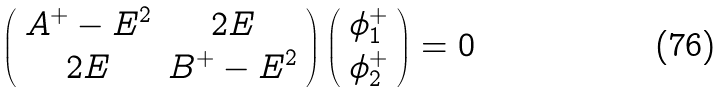<formula> <loc_0><loc_0><loc_500><loc_500>\left ( \begin{array} { c c } A ^ { + } - E ^ { 2 } & 2 E \\ 2 E & B ^ { + } - E ^ { 2 } \end{array} \right ) \left ( \begin{array} { c } \phi ^ { + } _ { 1 } \\ \phi ^ { + } _ { 2 } \end{array} \right ) = 0</formula> 